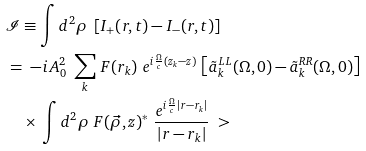<formula> <loc_0><loc_0><loc_500><loc_500>& \mathcal { I } \equiv \int d ^ { 2 } \rho \ \left [ I _ { + } ( r , t ) - I _ { - } ( r , t ) \right ] \\ & = \ - i \, A _ { 0 } ^ { 2 } \ \sum _ { k } \, F ( r _ { k } ) \ e ^ { i \frac { \Omega } { c } ( z _ { k } - z ) } \, \left [ \tilde { a } _ { k } ^ { L L } ( \Omega , 0 ) - \tilde { a } _ { k } ^ { R R } ( \Omega , 0 ) \right ] \\ & \quad \times \, \int d ^ { 2 } \rho \ F ( \vec { \rho } , z ) ^ { * } \ \frac { e ^ { i \frac { \Omega } { c } | r - r _ { k } | } } { | r - r _ { k } | } \ ></formula> 